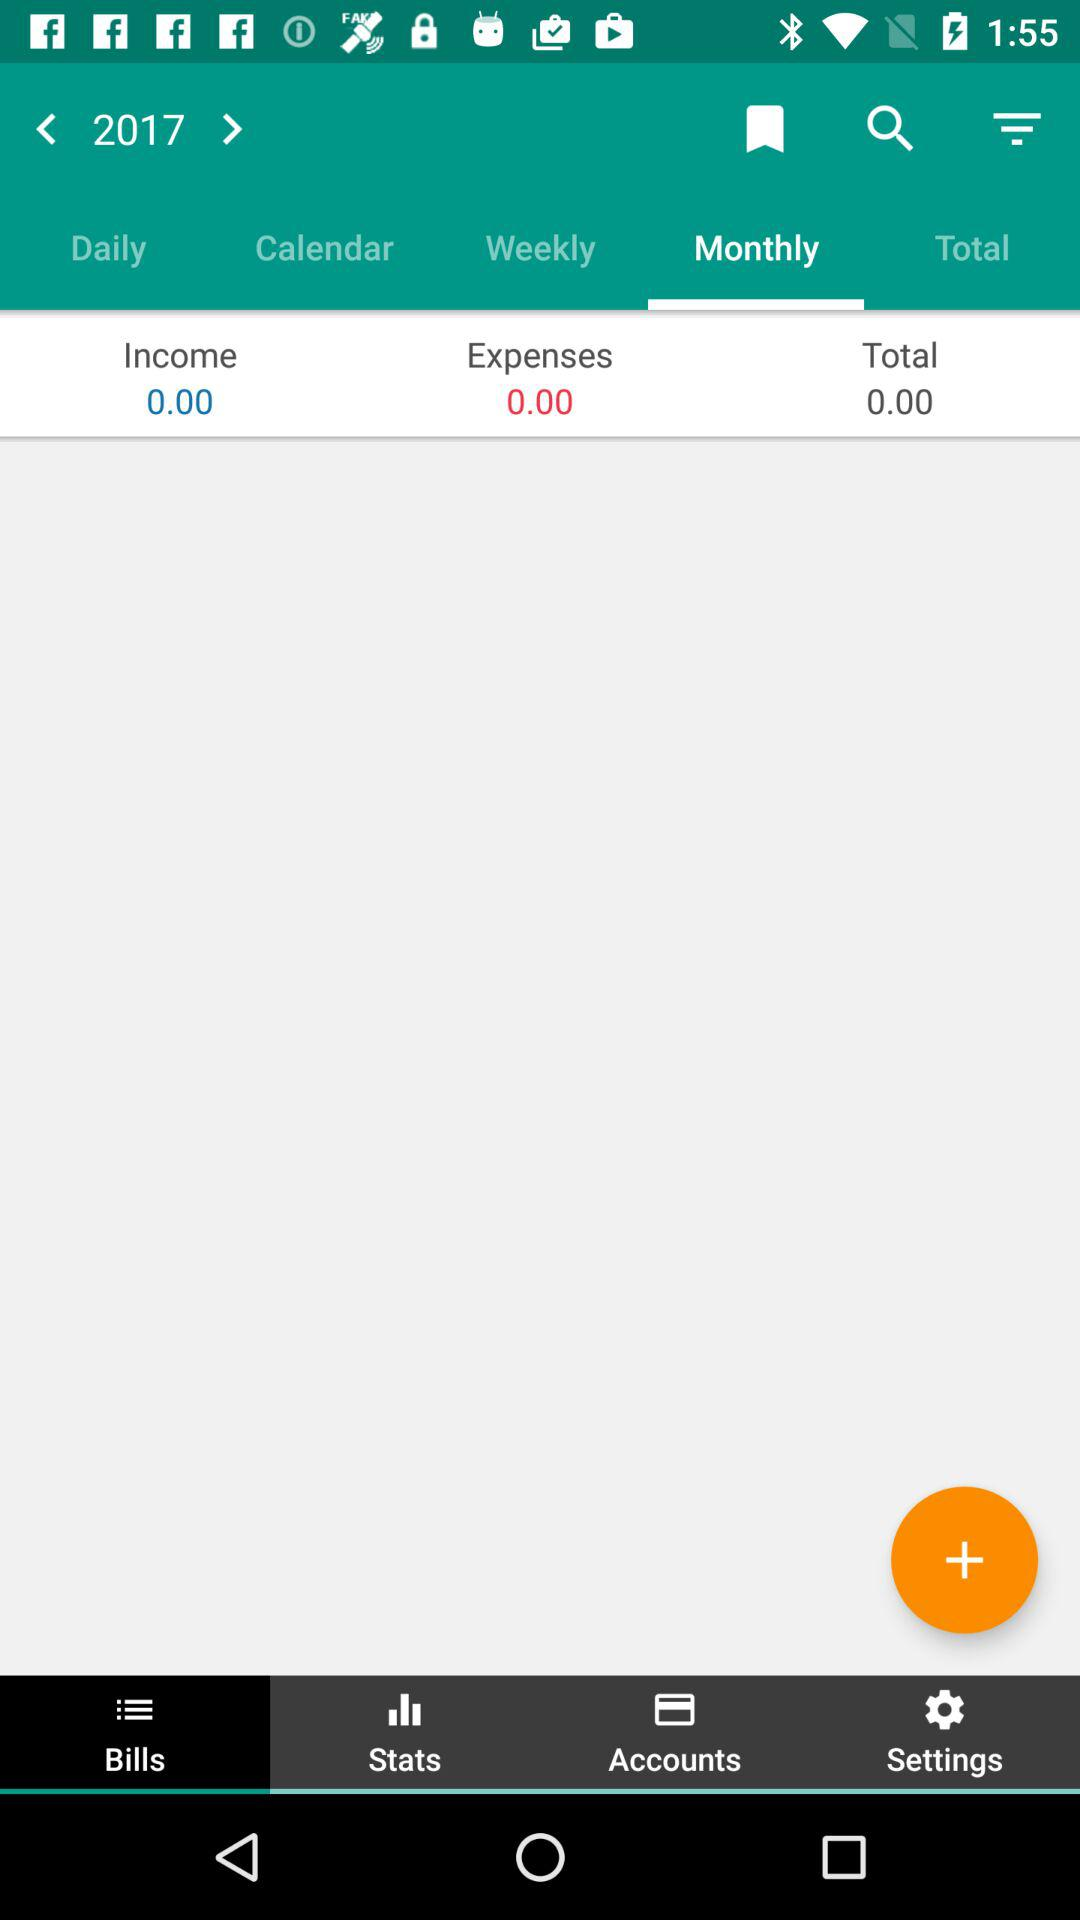Which button has been selected in the bottom row? The selected button is "Bills". 